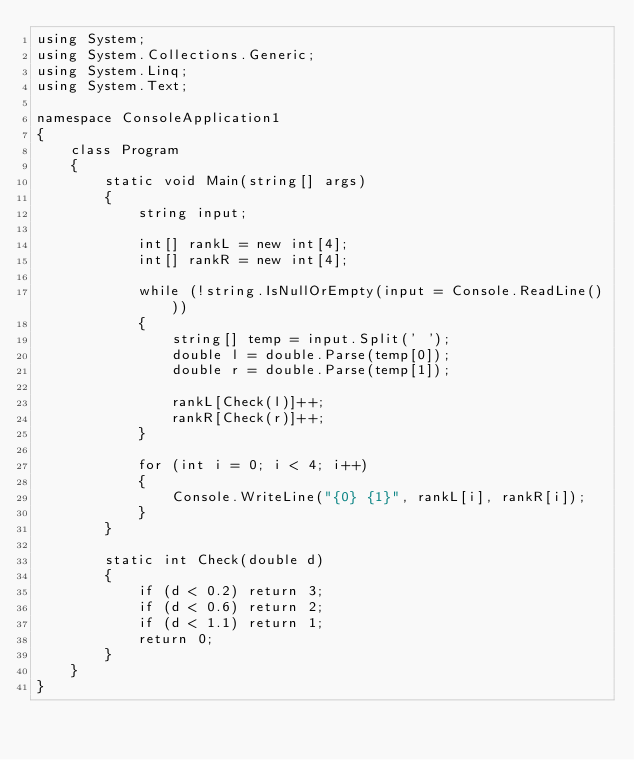<code> <loc_0><loc_0><loc_500><loc_500><_C#_>using System;
using System.Collections.Generic;
using System.Linq;
using System.Text;

namespace ConsoleApplication1
{
    class Program
    {
        static void Main(string[] args)
        {
            string input;

            int[] rankL = new int[4];
            int[] rankR = new int[4];

            while (!string.IsNullOrEmpty(input = Console.ReadLine()))
            {
                string[] temp = input.Split(' ');
                double l = double.Parse(temp[0]);
                double r = double.Parse(temp[1]);

                rankL[Check(l)]++;
                rankR[Check(r)]++;
            }

            for (int i = 0; i < 4; i++)
            {
                Console.WriteLine("{0} {1}", rankL[i], rankR[i]);
            }
        }

        static int Check(double d)
        {
            if (d < 0.2) return 3;
            if (d < 0.6) return 2;
            if (d < 1.1) return 1;
            return 0;
        }
    }
}</code> 